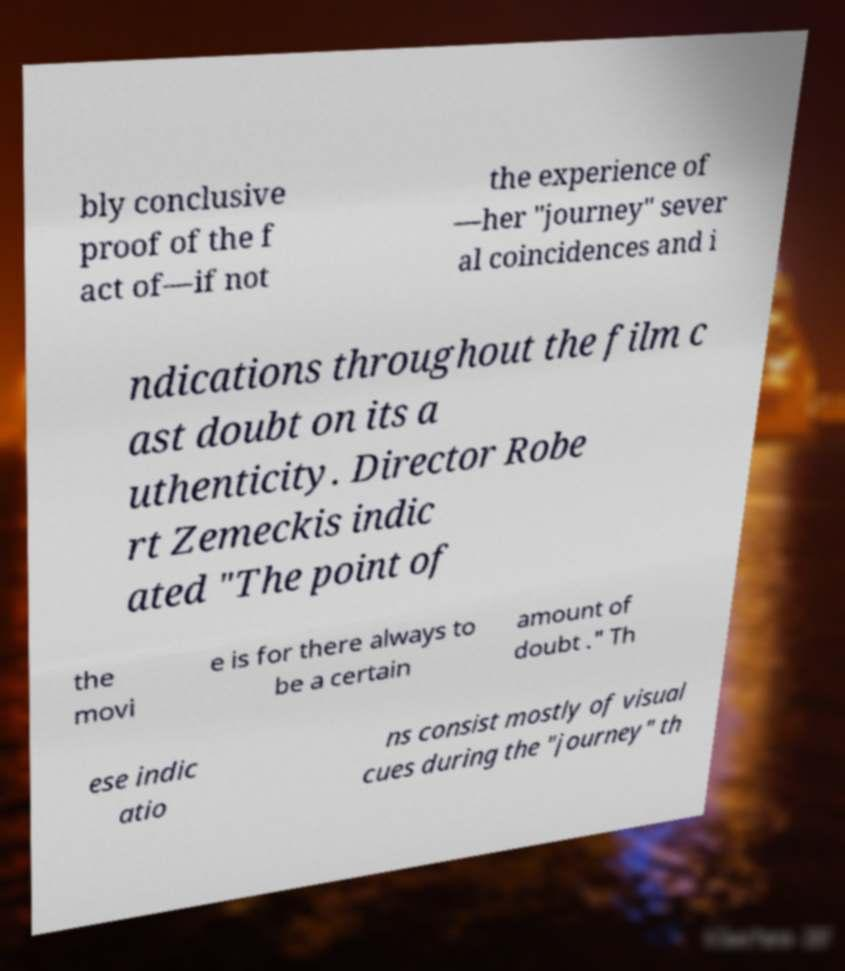Can you read and provide the text displayed in the image?This photo seems to have some interesting text. Can you extract and type it out for me? bly conclusive proof of the f act of—if not the experience of —her "journey" sever al coincidences and i ndications throughout the film c ast doubt on its a uthenticity. Director Robe rt Zemeckis indic ated "The point of the movi e is for there always to be a certain amount of doubt ." Th ese indic atio ns consist mostly of visual cues during the "journey" th 